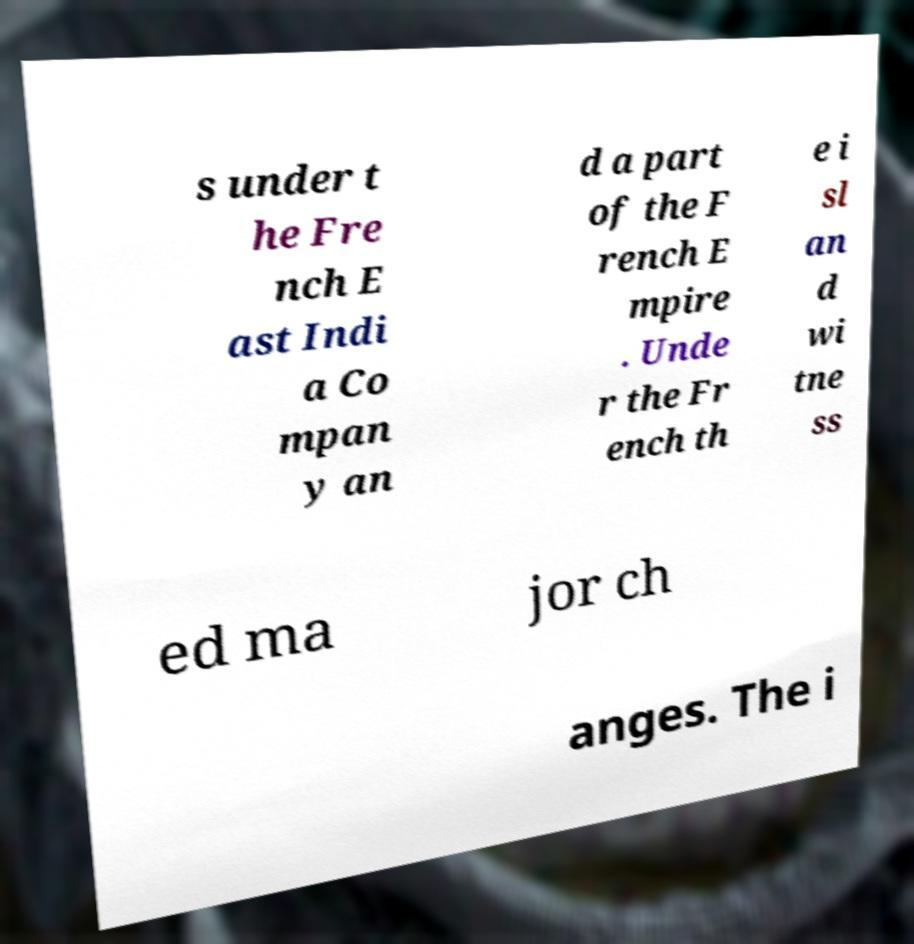Please identify and transcribe the text found in this image. s under t he Fre nch E ast Indi a Co mpan y an d a part of the F rench E mpire . Unde r the Fr ench th e i sl an d wi tne ss ed ma jor ch anges. The i 